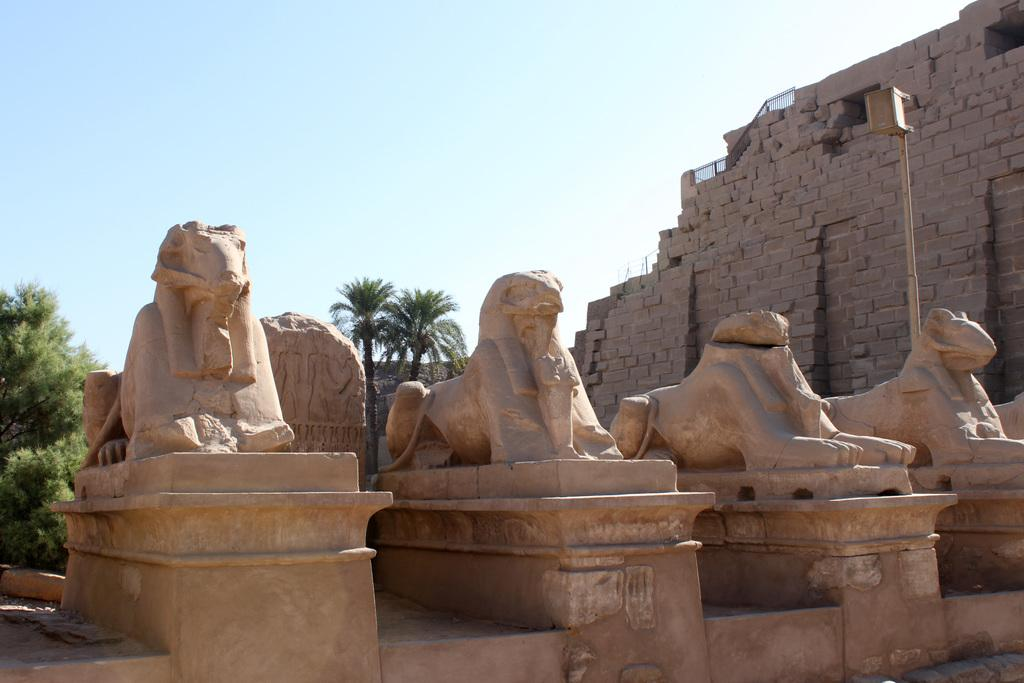What is the main subject in the image? There is a sculpture in the image. What other significant structure can be seen in the image? There is a monument in the image. What type of natural elements are visible in the background of the image? There are trees in the background of the image. What color is the sky in the background of the image? The sky is blue in the background of the image. What type of rod is being used for magic in the image? There is no rod or magic present in the image; it features a sculpture and a monument with trees and a blue sky in the background. 